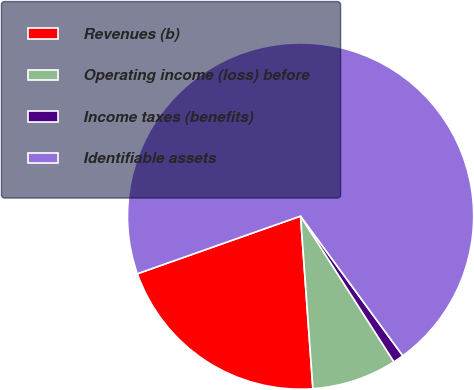Convert chart to OTSL. <chart><loc_0><loc_0><loc_500><loc_500><pie_chart><fcel>Revenues (b)<fcel>Operating income (loss) before<fcel>Income taxes (benefits)<fcel>Identifiable assets<nl><fcel>20.73%<fcel>7.93%<fcel>0.99%<fcel>70.35%<nl></chart> 